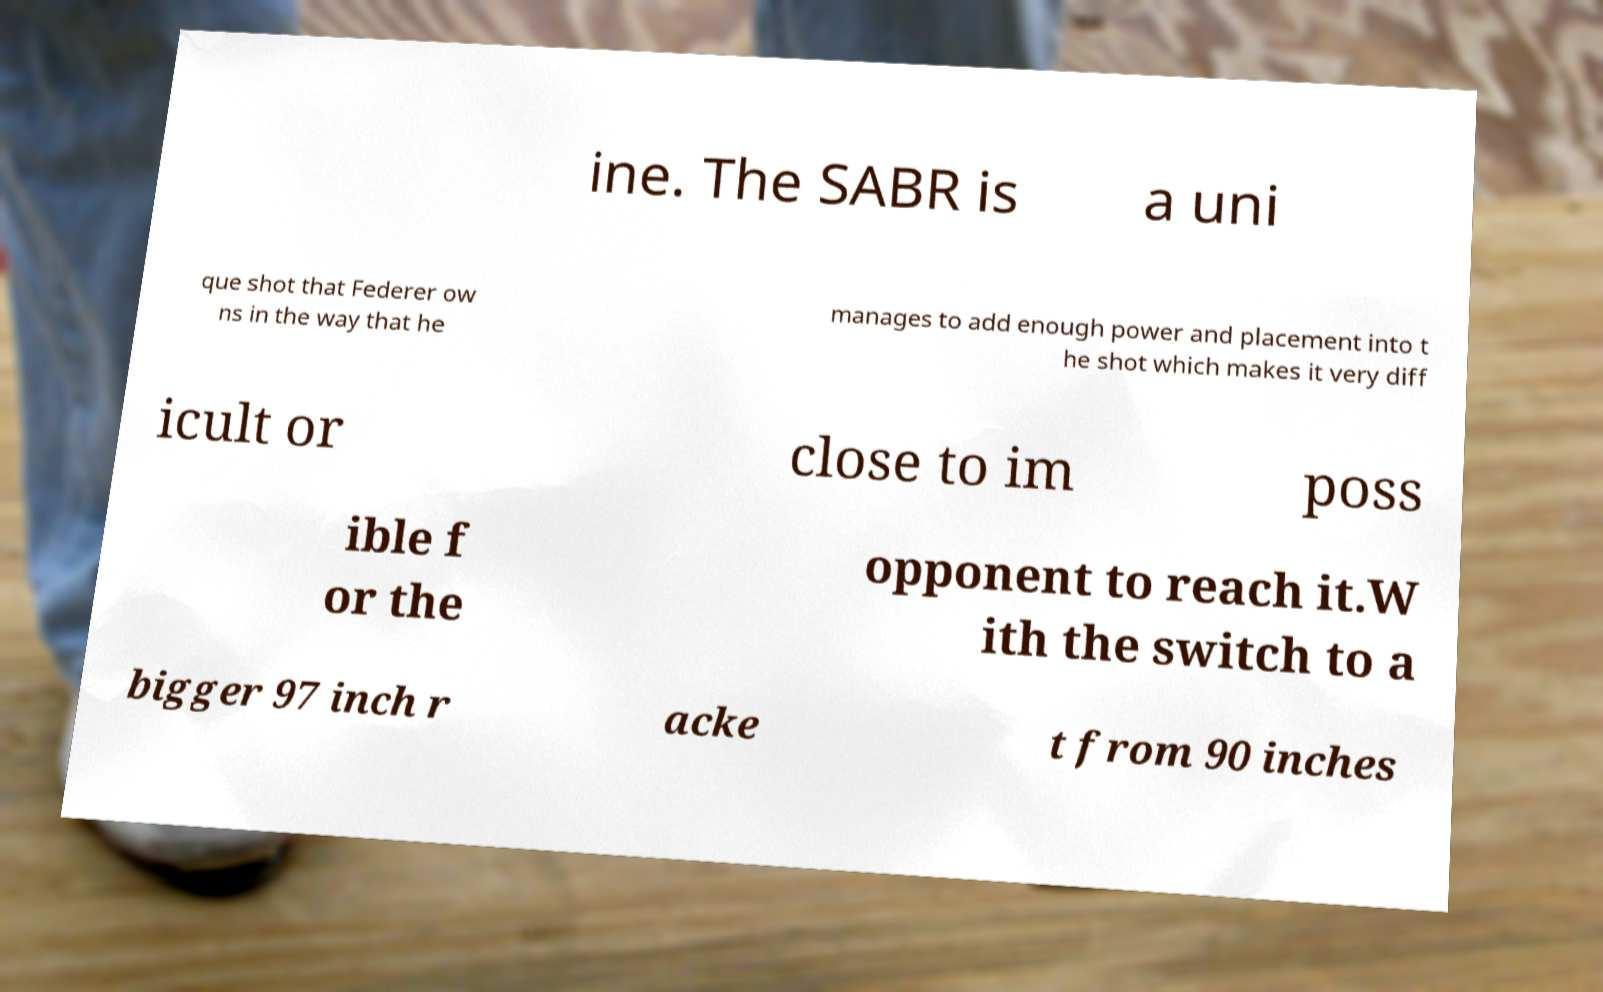There's text embedded in this image that I need extracted. Can you transcribe it verbatim? ine. The SABR is a uni que shot that Federer ow ns in the way that he manages to add enough power and placement into t he shot which makes it very diff icult or close to im poss ible f or the opponent to reach it.W ith the switch to a bigger 97 inch r acke t from 90 inches 